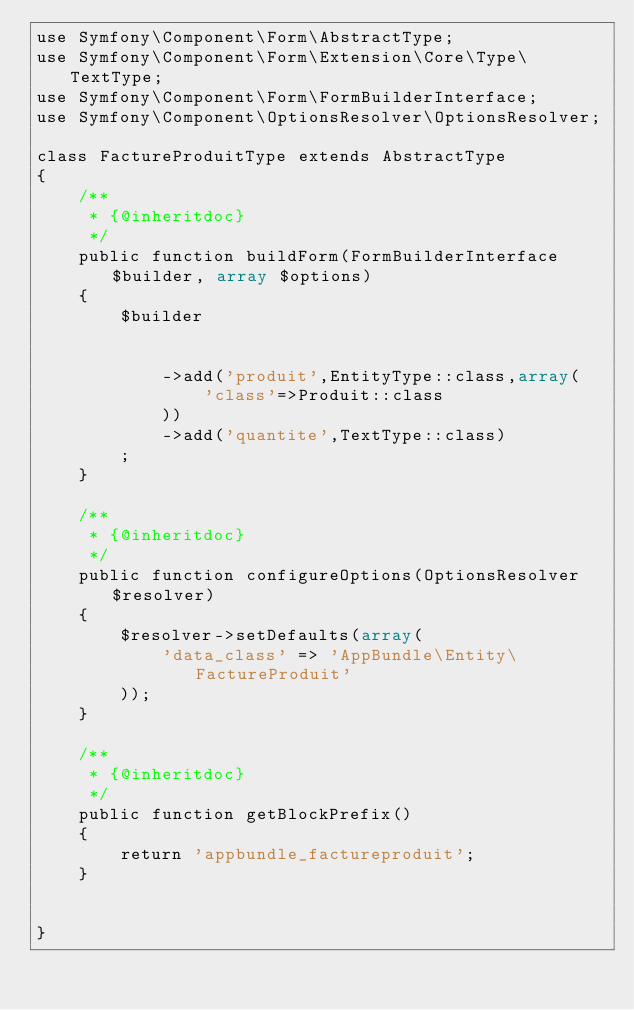<code> <loc_0><loc_0><loc_500><loc_500><_PHP_>use Symfony\Component\Form\AbstractType;
use Symfony\Component\Form\Extension\Core\Type\TextType;
use Symfony\Component\Form\FormBuilderInterface;
use Symfony\Component\OptionsResolver\OptionsResolver;

class FactureProduitType extends AbstractType
{
    /**
     * {@inheritdoc}
     */
    public function buildForm(FormBuilderInterface $builder, array $options)
    {
        $builder


            ->add('produit',EntityType::class,array(
                'class'=>Produit::class
            ))
            ->add('quantite',TextType::class)
        ;
    }

    /**
     * {@inheritdoc}
     */
    public function configureOptions(OptionsResolver $resolver)
    {
        $resolver->setDefaults(array(
            'data_class' => 'AppBundle\Entity\FactureProduit'
        ));
    }

    /**
     * {@inheritdoc}
     */
    public function getBlockPrefix()
    {
        return 'appbundle_factureproduit';
    }


}
</code> 